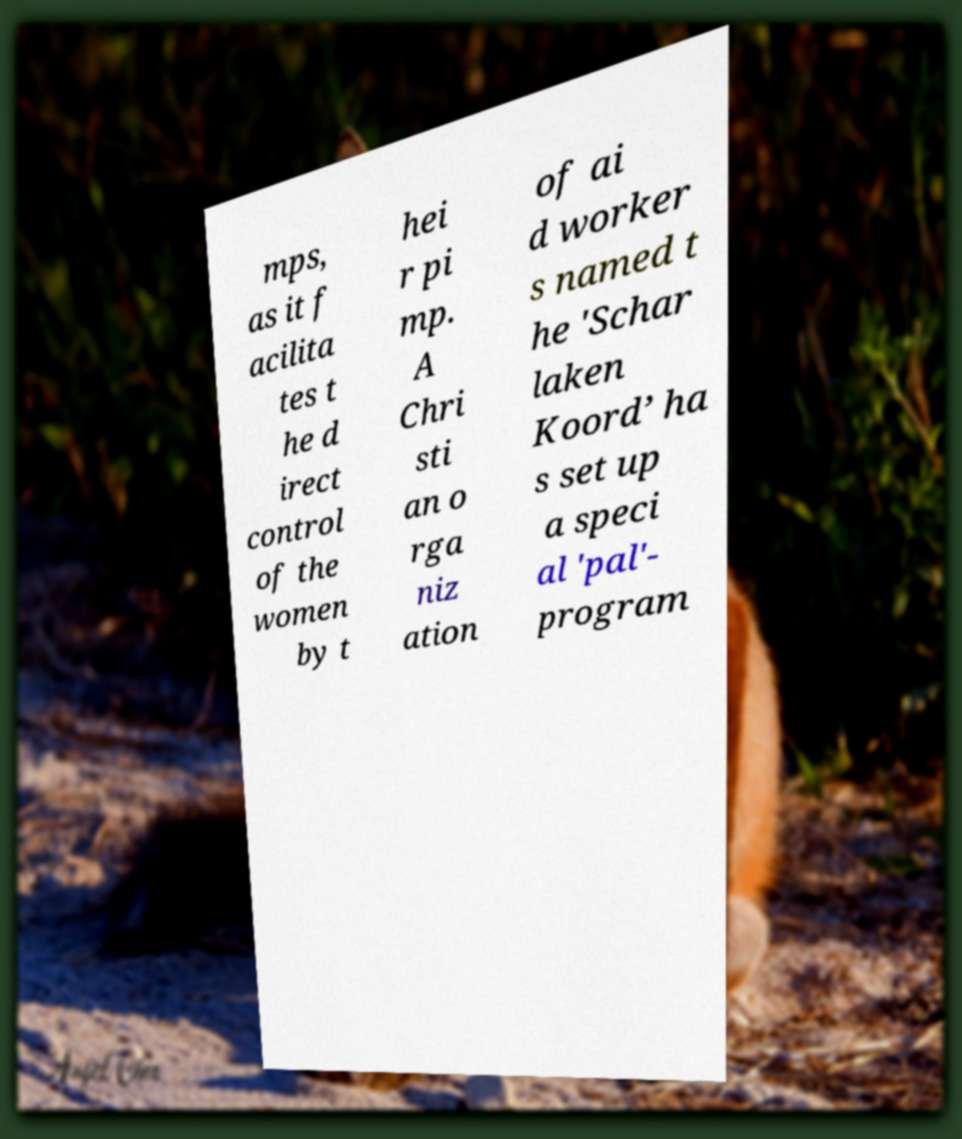Could you assist in decoding the text presented in this image and type it out clearly? mps, as it f acilita tes t he d irect control of the women by t hei r pi mp. A Chri sti an o rga niz ation of ai d worker s named t he 'Schar laken Koord’ ha s set up a speci al 'pal'- program 